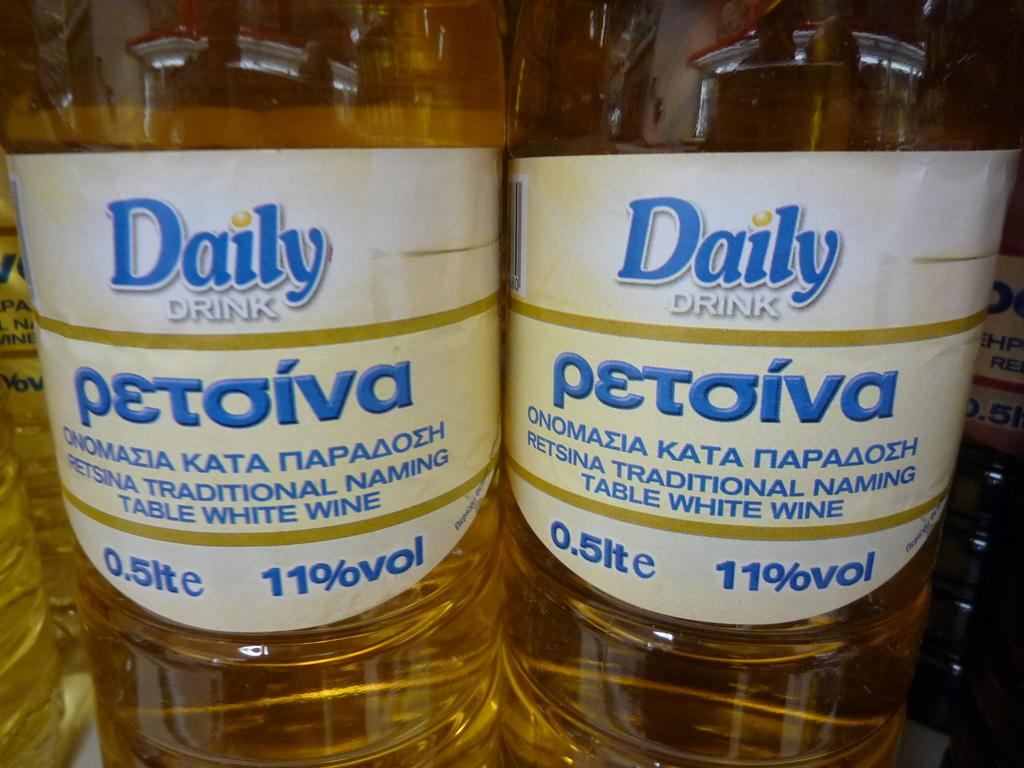Provide a one-sentence caption for the provided image. Two bottles of Daily Drink next to one another. 